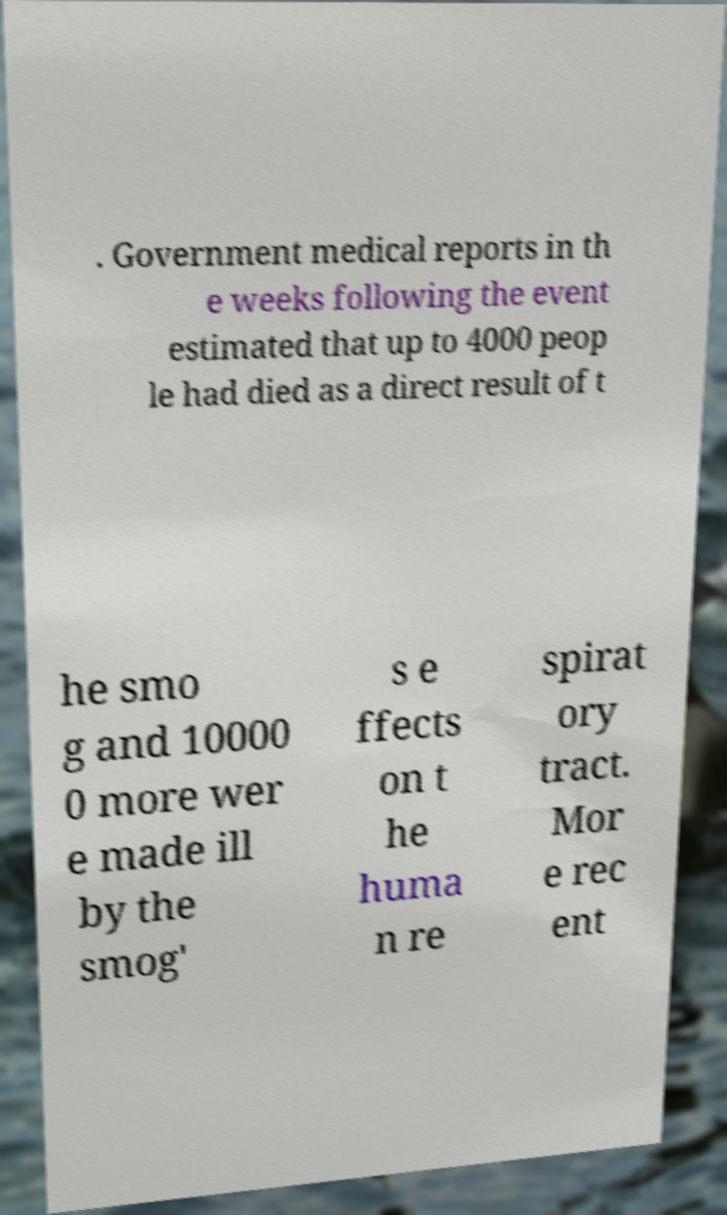Could you extract and type out the text from this image? . Government medical reports in th e weeks following the event estimated that up to 4000 peop le had died as a direct result of t he smo g and 10000 0 more wer e made ill by the smog' s e ffects on t he huma n re spirat ory tract. Mor e rec ent 